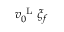<formula> <loc_0><loc_0><loc_500><loc_500>v _ { 0 } ^ { L } \xi _ { f }</formula> 